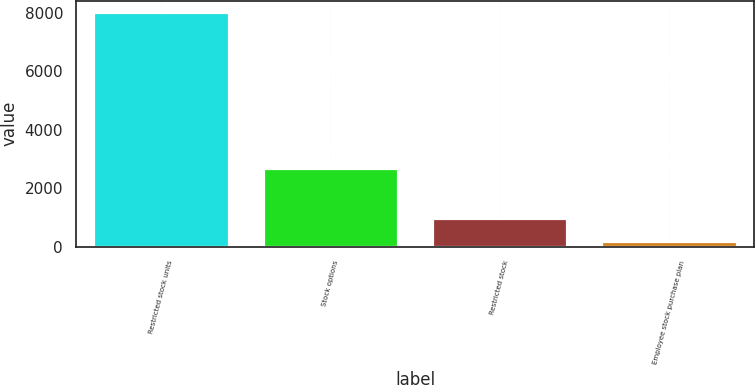Convert chart. <chart><loc_0><loc_0><loc_500><loc_500><bar_chart><fcel>Restricted stock units<fcel>Stock options<fcel>Restricted stock<fcel>Employee stock purchase plan<nl><fcel>8008<fcel>2679<fcel>996.1<fcel>217<nl></chart> 